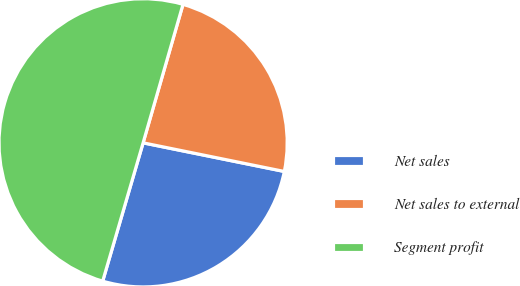Convert chart. <chart><loc_0><loc_0><loc_500><loc_500><pie_chart><fcel>Net sales<fcel>Net sales to external<fcel>Segment profit<nl><fcel>26.34%<fcel>23.72%<fcel>49.94%<nl></chart> 